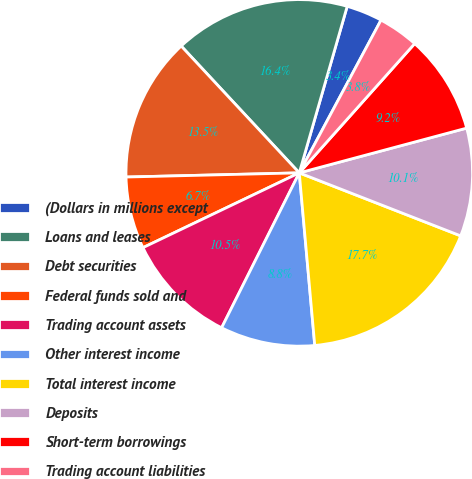<chart> <loc_0><loc_0><loc_500><loc_500><pie_chart><fcel>(Dollars in millions except<fcel>Loans and leases<fcel>Debt securities<fcel>Federal funds sold and<fcel>Trading account assets<fcel>Other interest income<fcel>Total interest income<fcel>Deposits<fcel>Short-term borrowings<fcel>Trading account liabilities<nl><fcel>3.36%<fcel>16.39%<fcel>13.45%<fcel>6.72%<fcel>10.5%<fcel>8.82%<fcel>17.65%<fcel>10.08%<fcel>9.24%<fcel>3.78%<nl></chart> 